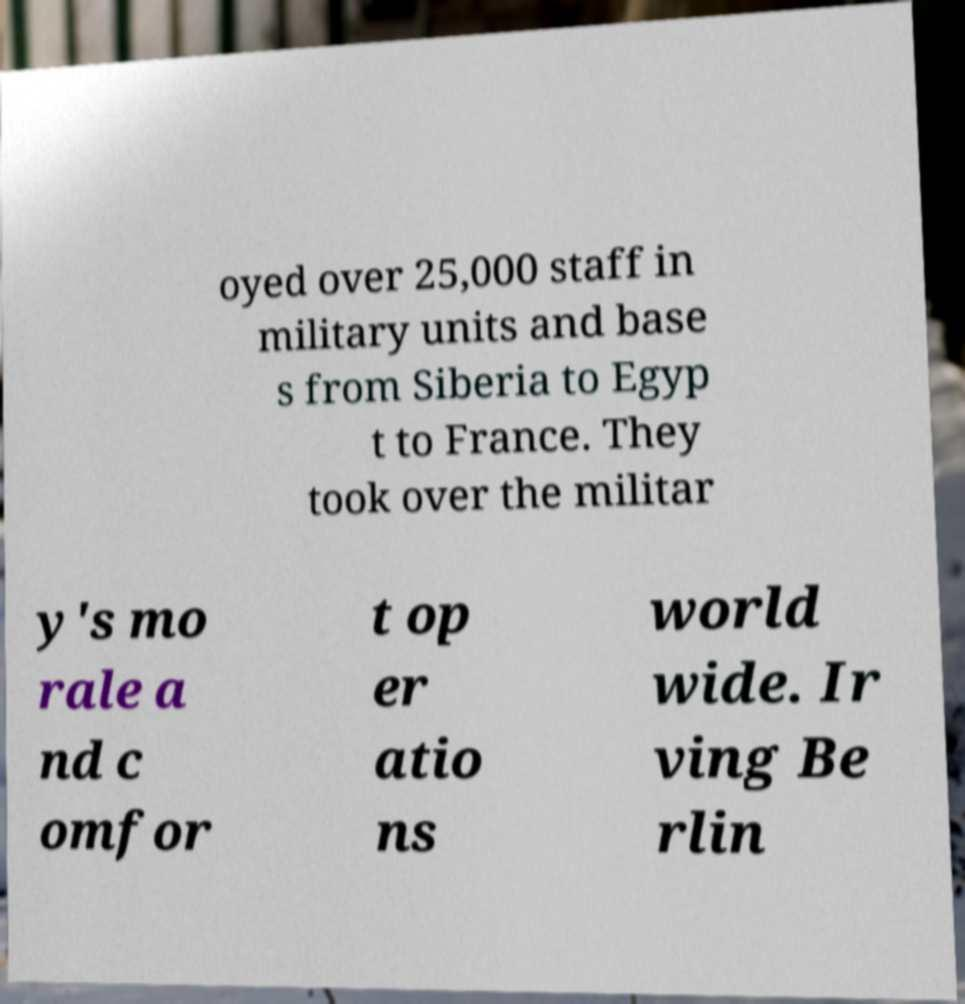What messages or text are displayed in this image? I need them in a readable, typed format. oyed over 25,000 staff in military units and base s from Siberia to Egyp t to France. They took over the militar y's mo rale a nd c omfor t op er atio ns world wide. Ir ving Be rlin 